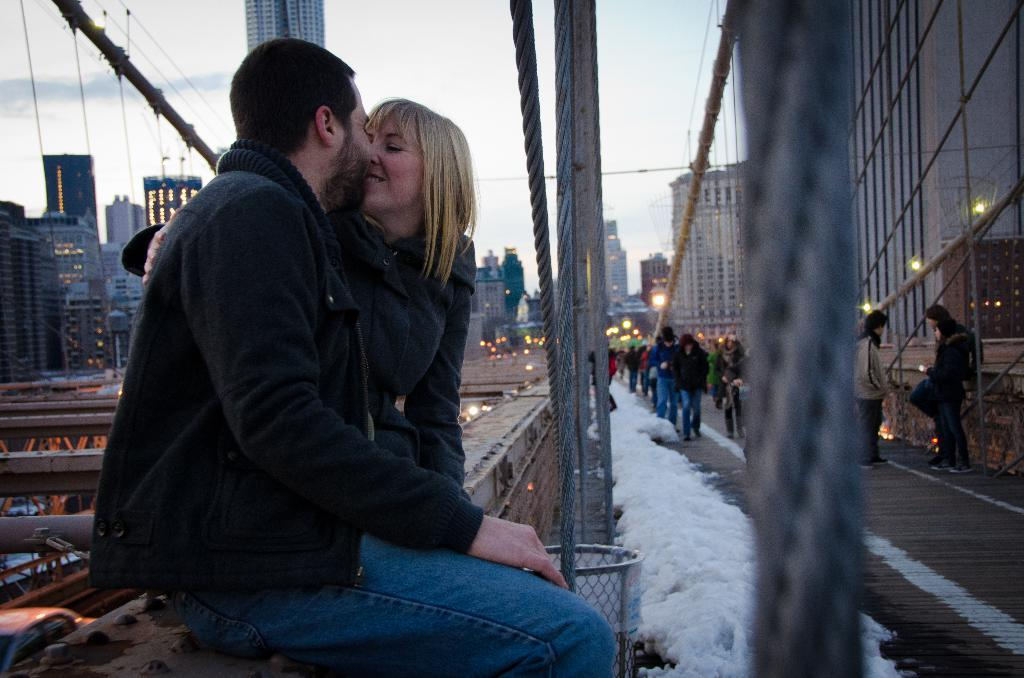How many people are sitting in the image? There are two people sitting in the image. What can be seen in the background of the image? Buildings, lights, and people walking are visible in the background. What object is present for waste disposal? A dustbin is visible in the image. What is the purpose of the rope in the image? The purpose of the rope is not clear from the image, but it is present. What is the weather like in the image? Snow is visible in the image, indicating a cold or wintry weather. What is the color of the sky in the image? The sky appears to be white in color. What type of berry is being used as a decoration on the rope in the image? There are no berries present in the image, and the rope does not appear to be used as a decoration. 